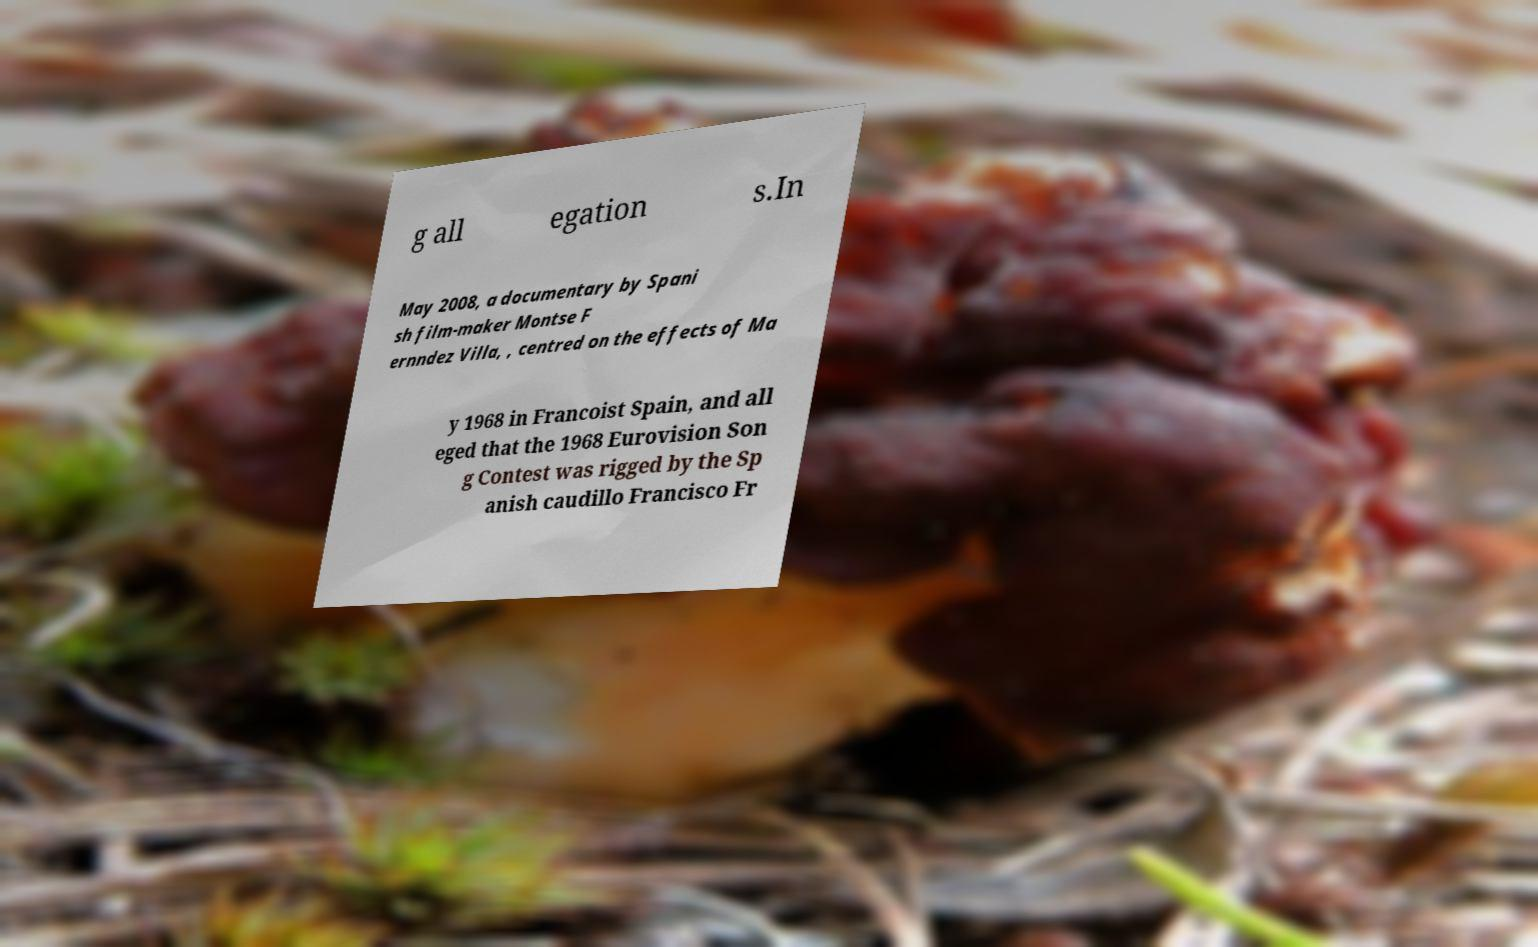I need the written content from this picture converted into text. Can you do that? g all egation s.In May 2008, a documentary by Spani sh film-maker Montse F ernndez Villa, , centred on the effects of Ma y 1968 in Francoist Spain, and all eged that the 1968 Eurovision Son g Contest was rigged by the Sp anish caudillo Francisco Fr 